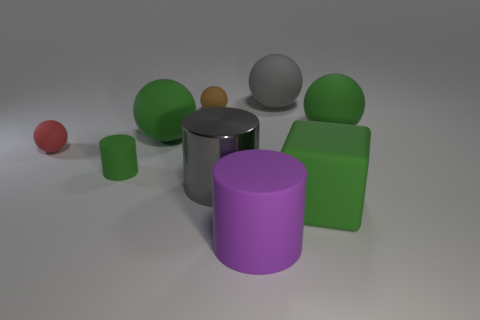Subtract all red rubber spheres. How many spheres are left? 4 Subtract all red cylinders. How many green balls are left? 2 Add 1 large rubber objects. How many objects exist? 10 Subtract all brown balls. How many balls are left? 4 Subtract 0 cyan cylinders. How many objects are left? 9 Subtract all balls. How many objects are left? 4 Subtract all cyan spheres. Subtract all cyan cubes. How many spheres are left? 5 Subtract all big purple cylinders. Subtract all cubes. How many objects are left? 7 Add 5 red rubber spheres. How many red rubber spheres are left? 6 Add 8 red things. How many red things exist? 9 